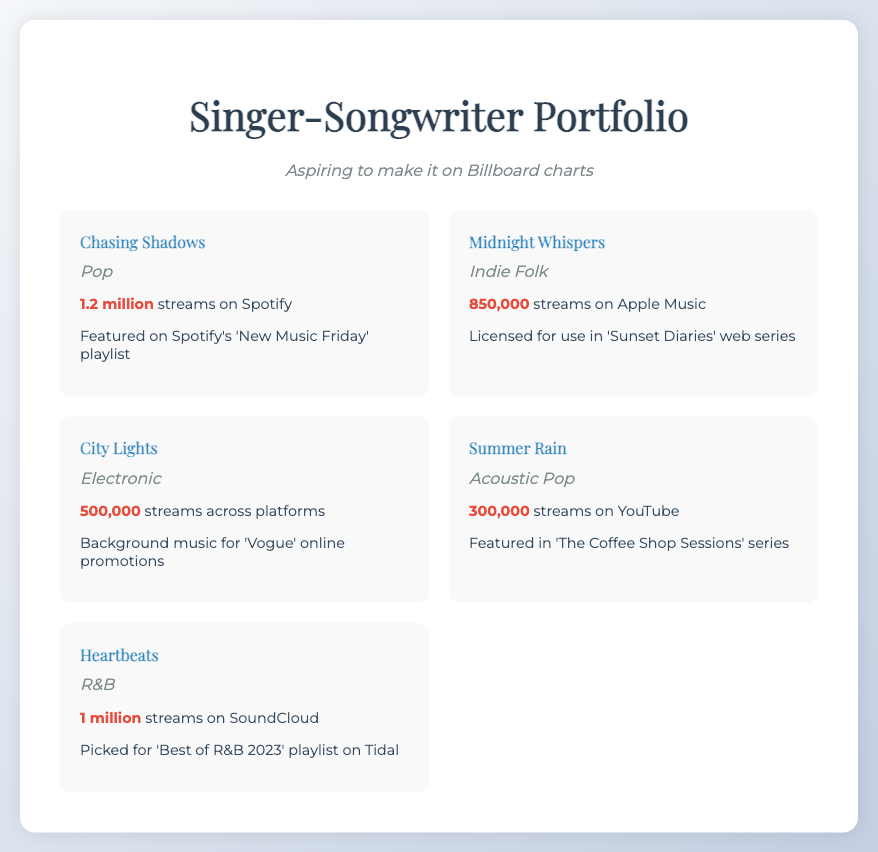what is the title of the first song? The first song listed in the document is "Chasing Shadows".
Answer: Chasing Shadows how many streams does "Heartbeats" have? "Heartbeats" has 1 million streams on SoundCloud, as mentioned in the document.
Answer: 1 million which song is featured on Spotify's 'New Music Friday'? The song featured on Spotify's 'New Music Friday' is "Chasing Shadows".
Answer: Chasing Shadows what genre is "Midnight Whispers"? The genre of "Midnight Whispers" is Indie Folk, as indicated in the document.
Answer: Indie Folk how many streams does "City Lights" have across platforms? "City Lights" has 500,000 streams across platforms, according to the document.
Answer: 500,000 which song was licensed for use in 'Sunset Diaries'? The song licensed for use in 'Sunset Diaries' is "Midnight Whispers".
Answer: Midnight Whispers what is the genre of the song with 300,000 streams on YouTube? The genre of the song "Summer Rain", which has 300,000 streams on YouTube, is Acoustic Pop.
Answer: Acoustic Pop which song is picked for 'Best of R&B 2023' playlist on Tidal? The song picked for 'Best of R&B 2023' playlist on Tidal is "Heartbeats".
Answer: Heartbeats how many streams does "Summer Rain" have? "Summer Rain" has 300,000 streams on YouTube, as stated in the document.
Answer: 300,000 